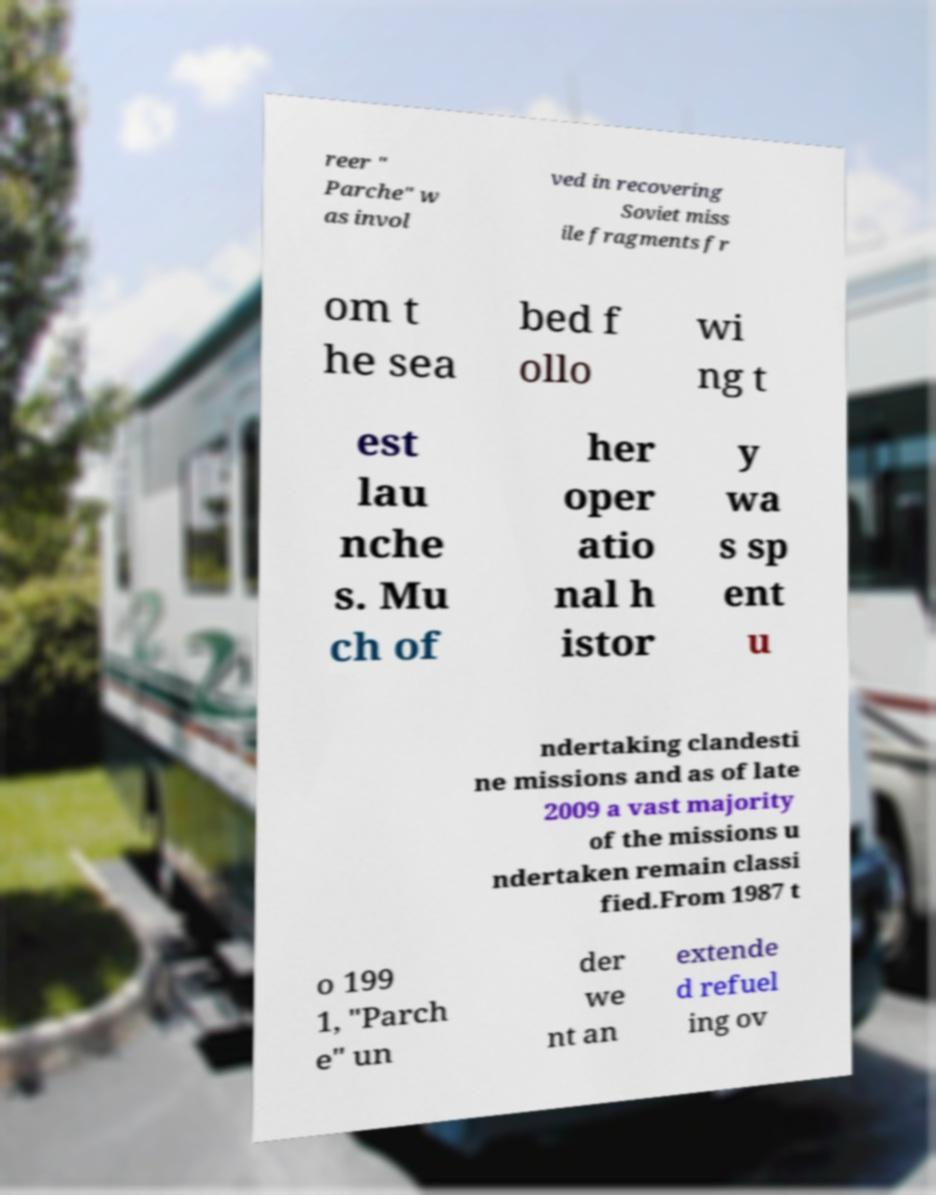Please identify and transcribe the text found in this image. reer " Parche" w as invol ved in recovering Soviet miss ile fragments fr om t he sea bed f ollo wi ng t est lau nche s. Mu ch of her oper atio nal h istor y wa s sp ent u ndertaking clandesti ne missions and as of late 2009 a vast majority of the missions u ndertaken remain classi fied.From 1987 t o 199 1, "Parch e" un der we nt an extende d refuel ing ov 